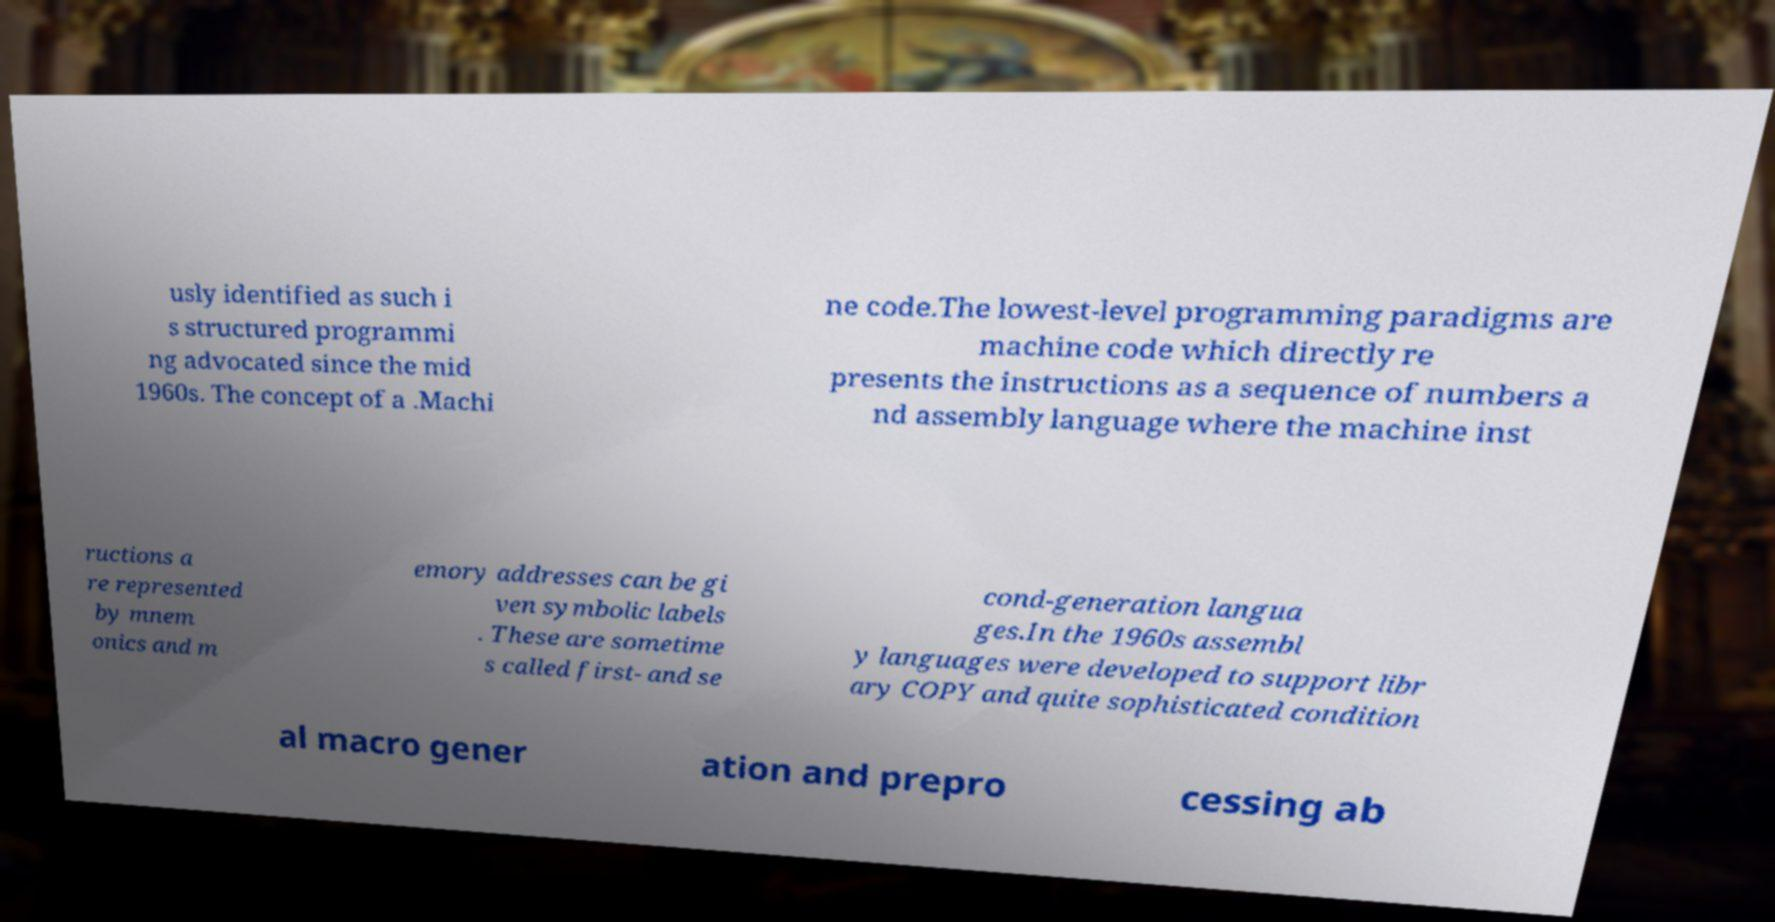Could you assist in decoding the text presented in this image and type it out clearly? usly identified as such i s structured programmi ng advocated since the mid 1960s. The concept of a .Machi ne code.The lowest-level programming paradigms are machine code which directly re presents the instructions as a sequence of numbers a nd assembly language where the machine inst ructions a re represented by mnem onics and m emory addresses can be gi ven symbolic labels . These are sometime s called first- and se cond-generation langua ges.In the 1960s assembl y languages were developed to support libr ary COPY and quite sophisticated condition al macro gener ation and prepro cessing ab 